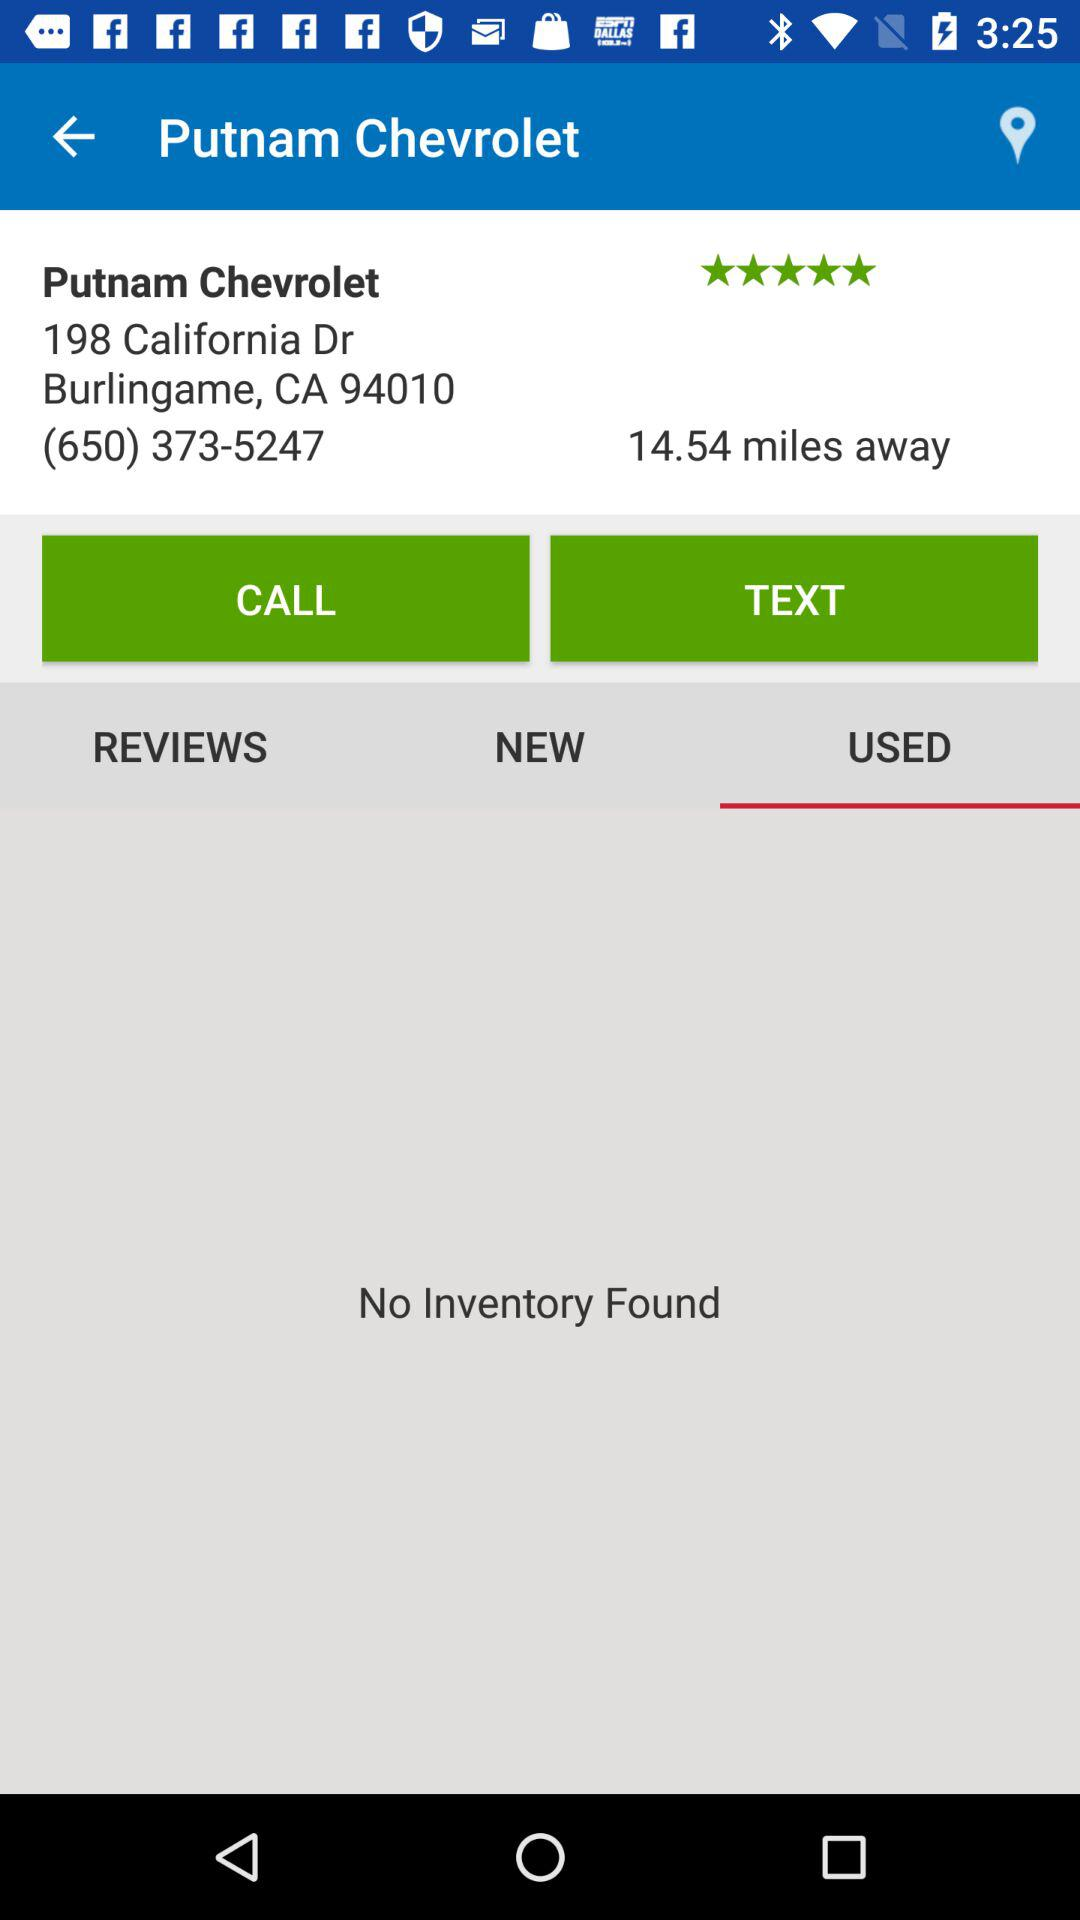What is the location of the "Putnam Chevrolet"? The location is 198 California Dr Bulingame, CA 94010. 